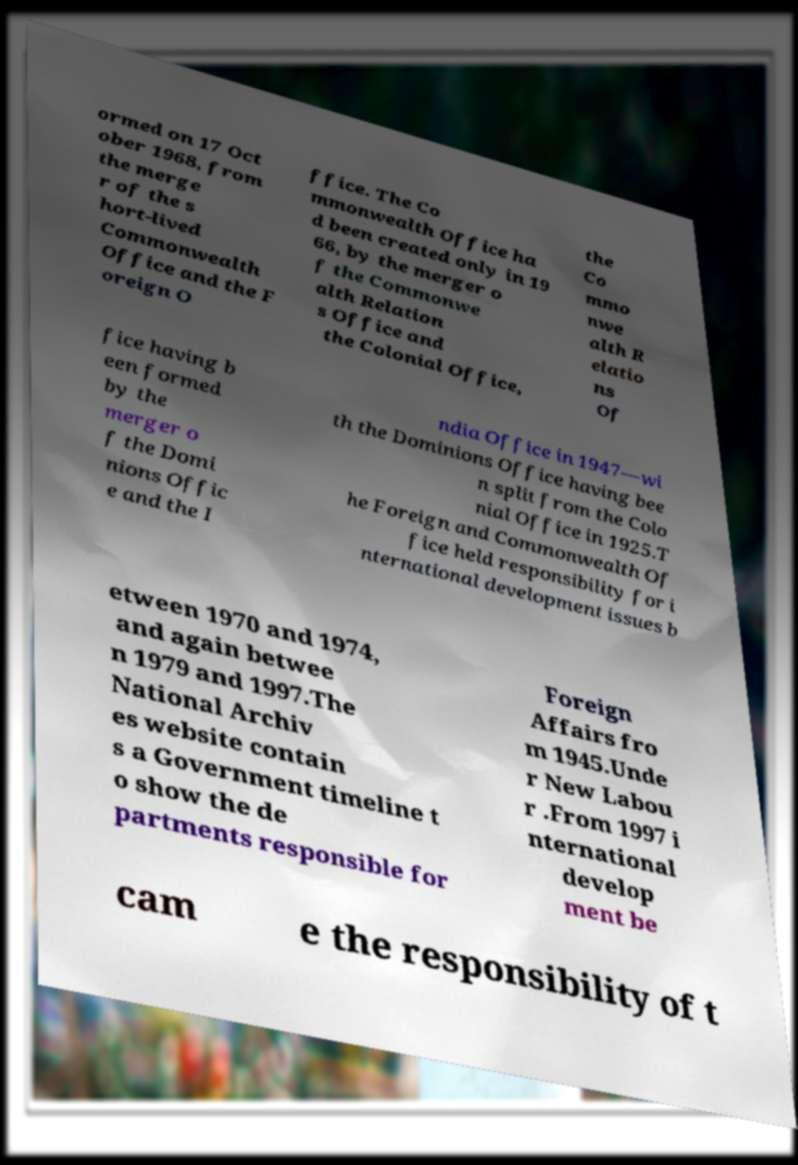I need the written content from this picture converted into text. Can you do that? ormed on 17 Oct ober 1968, from the merge r of the s hort-lived Commonwealth Office and the F oreign O ffice. The Co mmonwealth Office ha d been created only in 19 66, by the merger o f the Commonwe alth Relation s Office and the Colonial Office, the Co mmo nwe alth R elatio ns Of fice having b een formed by the merger o f the Domi nions Offic e and the I ndia Office in 1947—wi th the Dominions Office having bee n split from the Colo nial Office in 1925.T he Foreign and Commonwealth Of fice held responsibility for i nternational development issues b etween 1970 and 1974, and again betwee n 1979 and 1997.The National Archiv es website contain s a Government timeline t o show the de partments responsible for Foreign Affairs fro m 1945.Unde r New Labou r .From 1997 i nternational develop ment be cam e the responsibility of t 